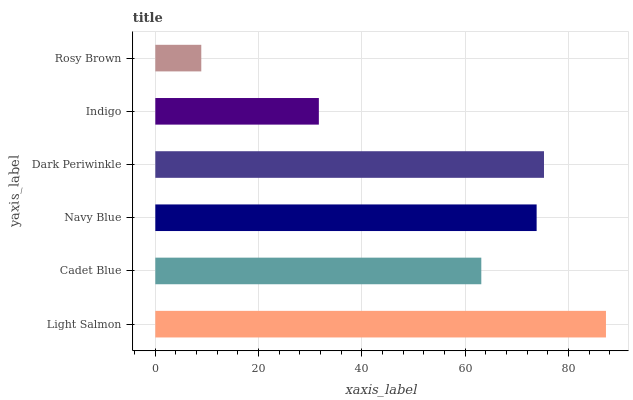Is Rosy Brown the minimum?
Answer yes or no. Yes. Is Light Salmon the maximum?
Answer yes or no. Yes. Is Cadet Blue the minimum?
Answer yes or no. No. Is Cadet Blue the maximum?
Answer yes or no. No. Is Light Salmon greater than Cadet Blue?
Answer yes or no. Yes. Is Cadet Blue less than Light Salmon?
Answer yes or no. Yes. Is Cadet Blue greater than Light Salmon?
Answer yes or no. No. Is Light Salmon less than Cadet Blue?
Answer yes or no. No. Is Navy Blue the high median?
Answer yes or no. Yes. Is Cadet Blue the low median?
Answer yes or no. Yes. Is Indigo the high median?
Answer yes or no. No. Is Navy Blue the low median?
Answer yes or no. No. 